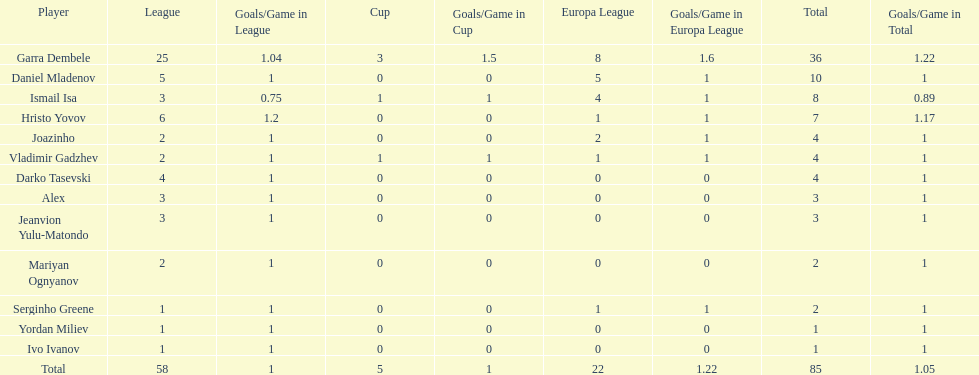Who was the top goalscorer on this team? Garra Dembele. 